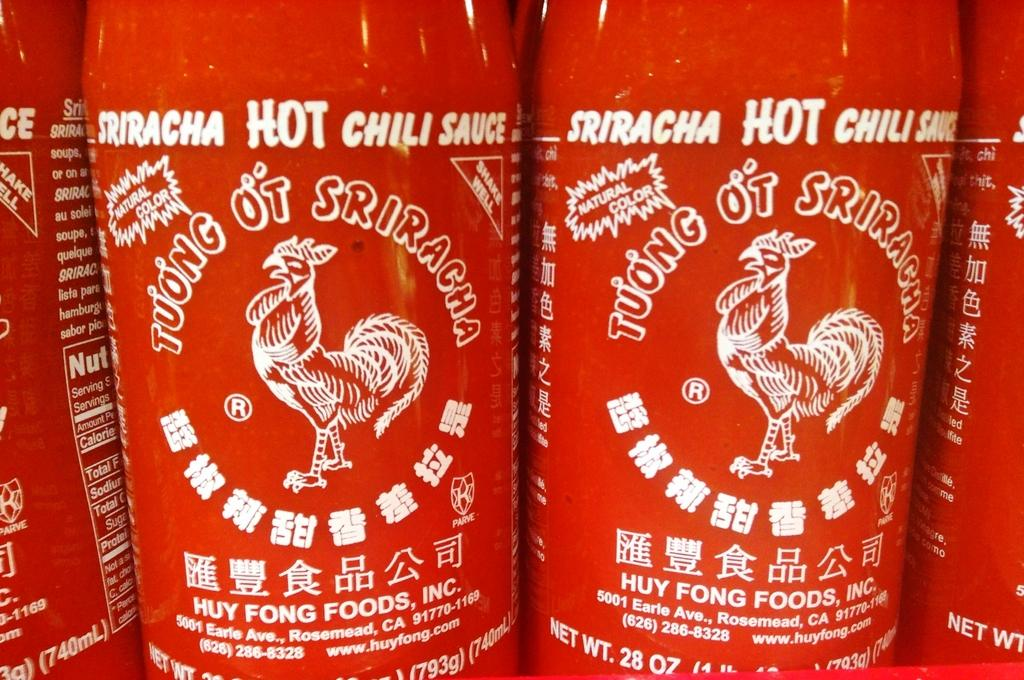<image>
Offer a succinct explanation of the picture presented. Red bottles of sriracha sauce are lined up next to each other. 